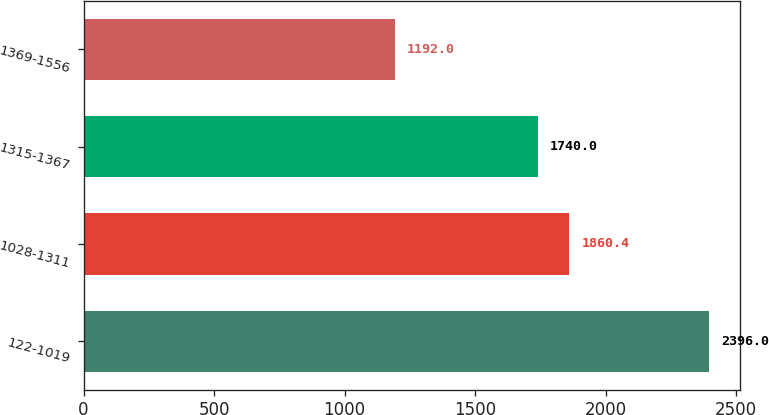Convert chart to OTSL. <chart><loc_0><loc_0><loc_500><loc_500><bar_chart><fcel>122-1019<fcel>1028-1311<fcel>1315-1367<fcel>1369-1556<nl><fcel>2396<fcel>1860.4<fcel>1740<fcel>1192<nl></chart> 